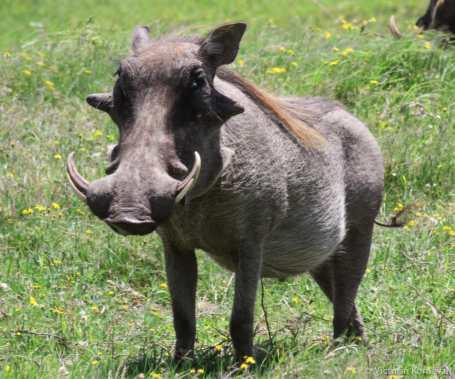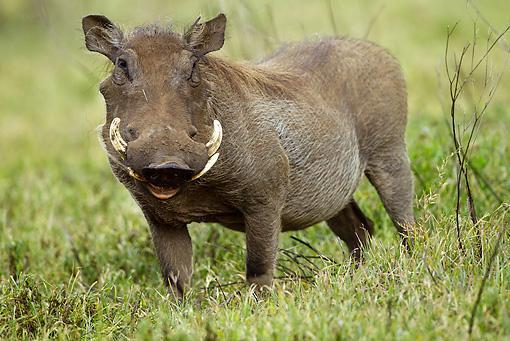The first image is the image on the left, the second image is the image on the right. Examine the images to the left and right. Is the description "There is more than one warthog in one of these images." accurate? Answer yes or no. No. 